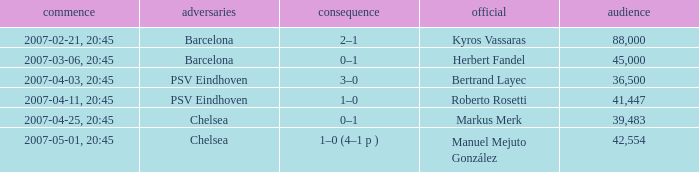Would you be able to parse every entry in this table? {'header': ['commence', 'adversaries', 'consequence', 'official', 'audience'], 'rows': [['2007-02-21, 20:45', 'Barcelona', '2–1', 'Kyros Vassaras', '88,000'], ['2007-03-06, 20:45', 'Barcelona', '0–1', 'Herbert Fandel', '45,000'], ['2007-04-03, 20:45', 'PSV Eindhoven', '3–0', 'Bertrand Layec', '36,500'], ['2007-04-11, 20:45', 'PSV Eindhoven', '1–0', 'Roberto Rosetti', '41,447'], ['2007-04-25, 20:45', 'Chelsea', '0–1', 'Markus Merk', '39,483'], ['2007-05-01, 20:45', 'Chelsea', '1–0 (4–1 p )', 'Manuel Mejuto González', '42,554']]} WHAT WAS THE SCORE OF THE GAME WITH A 2007-03-06, 20:45 KICKOFF? 0–1. 